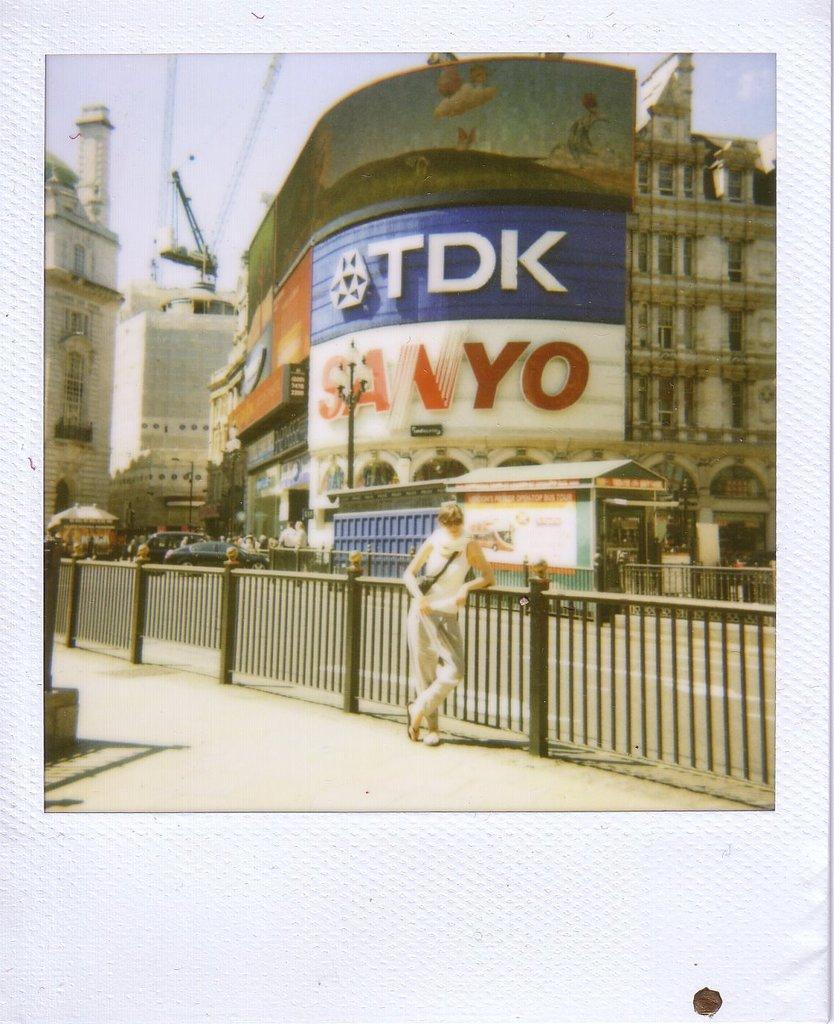How would you summarize this image in a sentence or two? A person is standing here, there are names on this building. At the top it is the sky. 